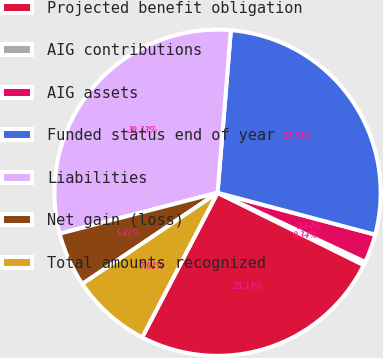Convert chart to OTSL. <chart><loc_0><loc_0><loc_500><loc_500><pie_chart><fcel>Projected benefit obligation<fcel>AIG contributions<fcel>AIG assets<fcel>Funded status end of year<fcel>Liabilities<fcel>Net gain (loss)<fcel>Total amounts recognized<nl><fcel>25.34%<fcel>0.34%<fcel>2.84%<fcel>27.84%<fcel>30.34%<fcel>5.41%<fcel>7.91%<nl></chart> 